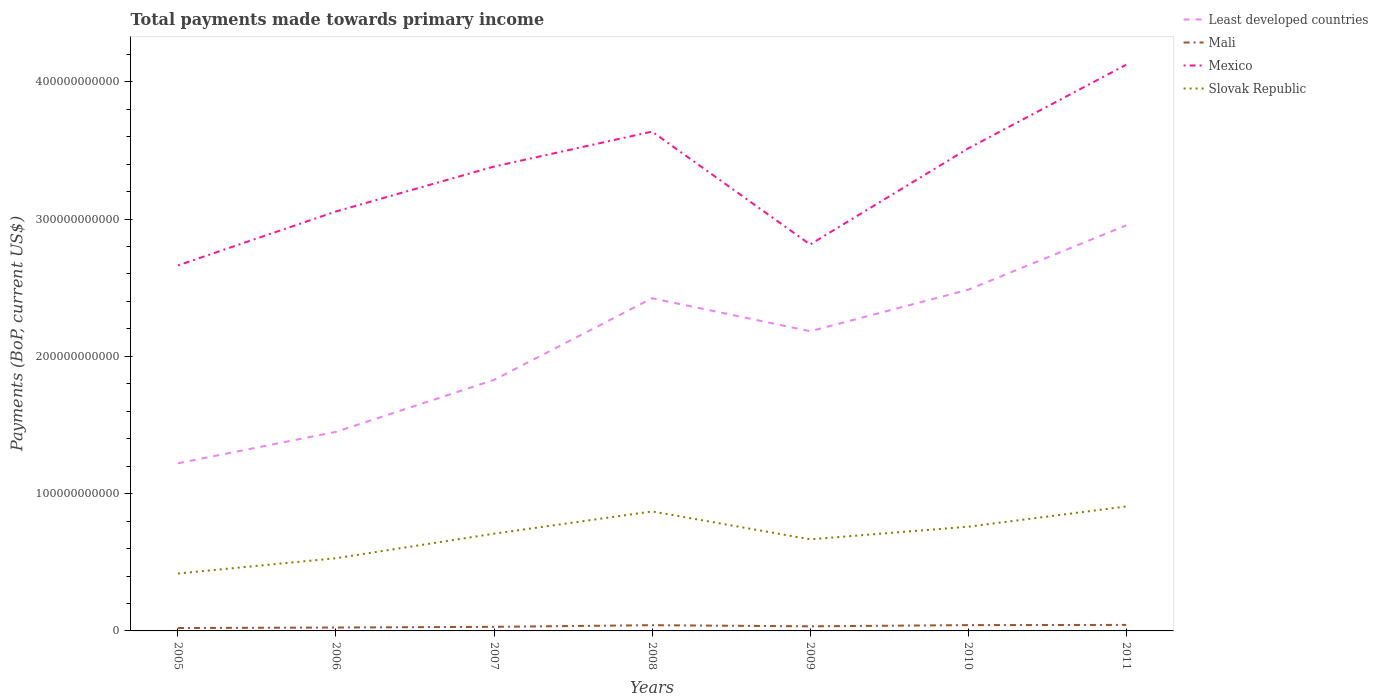How many different coloured lines are there?
Your answer should be compact. 4. Is the number of lines equal to the number of legend labels?
Your answer should be compact. Yes. Across all years, what is the maximum total payments made towards primary income in Mali?
Make the answer very short. 2.11e+09. What is the total total payments made towards primary income in Least developed countries in the graph?
Offer a very short reply. -9.62e+1. What is the difference between the highest and the second highest total payments made towards primary income in Slovak Republic?
Offer a very short reply. 4.88e+1. How many lines are there?
Your answer should be compact. 4. What is the difference between two consecutive major ticks on the Y-axis?
Make the answer very short. 1.00e+11. Does the graph contain any zero values?
Your answer should be compact. No. Does the graph contain grids?
Offer a terse response. No. Where does the legend appear in the graph?
Keep it short and to the point. Top right. How many legend labels are there?
Offer a terse response. 4. How are the legend labels stacked?
Give a very brief answer. Vertical. What is the title of the graph?
Offer a terse response. Total payments made towards primary income. What is the label or title of the Y-axis?
Make the answer very short. Payments (BoP, current US$). What is the Payments (BoP, current US$) in Least developed countries in 2005?
Provide a succinct answer. 1.22e+11. What is the Payments (BoP, current US$) in Mali in 2005?
Your answer should be compact. 2.11e+09. What is the Payments (BoP, current US$) in Mexico in 2005?
Ensure brevity in your answer.  2.66e+11. What is the Payments (BoP, current US$) of Slovak Republic in 2005?
Your response must be concise. 4.18e+1. What is the Payments (BoP, current US$) of Least developed countries in 2006?
Offer a very short reply. 1.45e+11. What is the Payments (BoP, current US$) in Mali in 2006?
Your answer should be compact. 2.48e+09. What is the Payments (BoP, current US$) of Mexico in 2006?
Provide a succinct answer. 3.06e+11. What is the Payments (BoP, current US$) of Slovak Republic in 2006?
Keep it short and to the point. 5.30e+1. What is the Payments (BoP, current US$) of Least developed countries in 2007?
Your answer should be very brief. 1.83e+11. What is the Payments (BoP, current US$) of Mali in 2007?
Ensure brevity in your answer.  2.99e+09. What is the Payments (BoP, current US$) in Mexico in 2007?
Offer a terse response. 3.38e+11. What is the Payments (BoP, current US$) of Slovak Republic in 2007?
Provide a short and direct response. 7.08e+1. What is the Payments (BoP, current US$) in Least developed countries in 2008?
Make the answer very short. 2.42e+11. What is the Payments (BoP, current US$) of Mali in 2008?
Provide a short and direct response. 4.17e+09. What is the Payments (BoP, current US$) of Mexico in 2008?
Ensure brevity in your answer.  3.64e+11. What is the Payments (BoP, current US$) in Slovak Republic in 2008?
Your answer should be very brief. 8.70e+1. What is the Payments (BoP, current US$) in Least developed countries in 2009?
Provide a short and direct response. 2.18e+11. What is the Payments (BoP, current US$) in Mali in 2009?
Your response must be concise. 3.35e+09. What is the Payments (BoP, current US$) in Mexico in 2009?
Provide a succinct answer. 2.82e+11. What is the Payments (BoP, current US$) in Slovak Republic in 2009?
Your response must be concise. 6.67e+1. What is the Payments (BoP, current US$) of Least developed countries in 2010?
Your answer should be compact. 2.49e+11. What is the Payments (BoP, current US$) of Mali in 2010?
Your answer should be compact. 4.24e+09. What is the Payments (BoP, current US$) in Mexico in 2010?
Provide a short and direct response. 3.51e+11. What is the Payments (BoP, current US$) of Slovak Republic in 2010?
Provide a succinct answer. 7.59e+1. What is the Payments (BoP, current US$) of Least developed countries in 2011?
Your answer should be very brief. 2.95e+11. What is the Payments (BoP, current US$) of Mali in 2011?
Offer a very short reply. 4.37e+09. What is the Payments (BoP, current US$) in Mexico in 2011?
Provide a short and direct response. 4.12e+11. What is the Payments (BoP, current US$) of Slovak Republic in 2011?
Provide a short and direct response. 9.07e+1. Across all years, what is the maximum Payments (BoP, current US$) of Least developed countries?
Offer a very short reply. 2.95e+11. Across all years, what is the maximum Payments (BoP, current US$) of Mali?
Your answer should be compact. 4.37e+09. Across all years, what is the maximum Payments (BoP, current US$) of Mexico?
Your response must be concise. 4.12e+11. Across all years, what is the maximum Payments (BoP, current US$) of Slovak Republic?
Give a very brief answer. 9.07e+1. Across all years, what is the minimum Payments (BoP, current US$) of Least developed countries?
Provide a short and direct response. 1.22e+11. Across all years, what is the minimum Payments (BoP, current US$) in Mali?
Offer a very short reply. 2.11e+09. Across all years, what is the minimum Payments (BoP, current US$) in Mexico?
Keep it short and to the point. 2.66e+11. Across all years, what is the minimum Payments (BoP, current US$) of Slovak Republic?
Provide a succinct answer. 4.18e+1. What is the total Payments (BoP, current US$) of Least developed countries in the graph?
Make the answer very short. 1.45e+12. What is the total Payments (BoP, current US$) of Mali in the graph?
Keep it short and to the point. 2.37e+1. What is the total Payments (BoP, current US$) of Mexico in the graph?
Provide a succinct answer. 2.32e+12. What is the total Payments (BoP, current US$) in Slovak Republic in the graph?
Your response must be concise. 4.86e+11. What is the difference between the Payments (BoP, current US$) of Least developed countries in 2005 and that in 2006?
Make the answer very short. -2.29e+1. What is the difference between the Payments (BoP, current US$) of Mali in 2005 and that in 2006?
Keep it short and to the point. -3.68e+08. What is the difference between the Payments (BoP, current US$) in Mexico in 2005 and that in 2006?
Ensure brevity in your answer.  -3.93e+1. What is the difference between the Payments (BoP, current US$) of Slovak Republic in 2005 and that in 2006?
Offer a terse response. -1.11e+1. What is the difference between the Payments (BoP, current US$) in Least developed countries in 2005 and that in 2007?
Offer a terse response. -6.07e+1. What is the difference between the Payments (BoP, current US$) of Mali in 2005 and that in 2007?
Your response must be concise. -8.77e+08. What is the difference between the Payments (BoP, current US$) of Mexico in 2005 and that in 2007?
Your response must be concise. -7.20e+1. What is the difference between the Payments (BoP, current US$) in Slovak Republic in 2005 and that in 2007?
Keep it short and to the point. -2.90e+1. What is the difference between the Payments (BoP, current US$) in Least developed countries in 2005 and that in 2008?
Provide a succinct answer. -1.20e+11. What is the difference between the Payments (BoP, current US$) of Mali in 2005 and that in 2008?
Make the answer very short. -2.06e+09. What is the difference between the Payments (BoP, current US$) of Mexico in 2005 and that in 2008?
Provide a short and direct response. -9.74e+1. What is the difference between the Payments (BoP, current US$) of Slovak Republic in 2005 and that in 2008?
Provide a short and direct response. -4.52e+1. What is the difference between the Payments (BoP, current US$) in Least developed countries in 2005 and that in 2009?
Ensure brevity in your answer.  -9.62e+1. What is the difference between the Payments (BoP, current US$) of Mali in 2005 and that in 2009?
Keep it short and to the point. -1.24e+09. What is the difference between the Payments (BoP, current US$) in Mexico in 2005 and that in 2009?
Ensure brevity in your answer.  -1.52e+1. What is the difference between the Payments (BoP, current US$) in Slovak Republic in 2005 and that in 2009?
Give a very brief answer. -2.49e+1. What is the difference between the Payments (BoP, current US$) in Least developed countries in 2005 and that in 2010?
Give a very brief answer. -1.26e+11. What is the difference between the Payments (BoP, current US$) of Mali in 2005 and that in 2010?
Your answer should be very brief. -2.13e+09. What is the difference between the Payments (BoP, current US$) of Mexico in 2005 and that in 2010?
Provide a succinct answer. -8.52e+1. What is the difference between the Payments (BoP, current US$) of Slovak Republic in 2005 and that in 2010?
Your response must be concise. -3.41e+1. What is the difference between the Payments (BoP, current US$) of Least developed countries in 2005 and that in 2011?
Keep it short and to the point. -1.73e+11. What is the difference between the Payments (BoP, current US$) of Mali in 2005 and that in 2011?
Give a very brief answer. -2.26e+09. What is the difference between the Payments (BoP, current US$) of Mexico in 2005 and that in 2011?
Your response must be concise. -1.46e+11. What is the difference between the Payments (BoP, current US$) of Slovak Republic in 2005 and that in 2011?
Provide a short and direct response. -4.88e+1. What is the difference between the Payments (BoP, current US$) of Least developed countries in 2006 and that in 2007?
Make the answer very short. -3.78e+1. What is the difference between the Payments (BoP, current US$) of Mali in 2006 and that in 2007?
Provide a short and direct response. -5.09e+08. What is the difference between the Payments (BoP, current US$) in Mexico in 2006 and that in 2007?
Provide a succinct answer. -3.27e+1. What is the difference between the Payments (BoP, current US$) in Slovak Republic in 2006 and that in 2007?
Give a very brief answer. -1.79e+1. What is the difference between the Payments (BoP, current US$) in Least developed countries in 2006 and that in 2008?
Your response must be concise. -9.73e+1. What is the difference between the Payments (BoP, current US$) of Mali in 2006 and that in 2008?
Make the answer very short. -1.70e+09. What is the difference between the Payments (BoP, current US$) of Mexico in 2006 and that in 2008?
Ensure brevity in your answer.  -5.82e+1. What is the difference between the Payments (BoP, current US$) of Slovak Republic in 2006 and that in 2008?
Provide a short and direct response. -3.41e+1. What is the difference between the Payments (BoP, current US$) of Least developed countries in 2006 and that in 2009?
Provide a short and direct response. -7.33e+1. What is the difference between the Payments (BoP, current US$) of Mali in 2006 and that in 2009?
Give a very brief answer. -8.75e+08. What is the difference between the Payments (BoP, current US$) in Mexico in 2006 and that in 2009?
Your answer should be very brief. 2.40e+1. What is the difference between the Payments (BoP, current US$) of Slovak Republic in 2006 and that in 2009?
Keep it short and to the point. -1.38e+1. What is the difference between the Payments (BoP, current US$) of Least developed countries in 2006 and that in 2010?
Your answer should be very brief. -1.04e+11. What is the difference between the Payments (BoP, current US$) of Mali in 2006 and that in 2010?
Offer a terse response. -1.76e+09. What is the difference between the Payments (BoP, current US$) of Mexico in 2006 and that in 2010?
Provide a succinct answer. -4.59e+1. What is the difference between the Payments (BoP, current US$) of Slovak Republic in 2006 and that in 2010?
Your answer should be compact. -2.30e+1. What is the difference between the Payments (BoP, current US$) in Least developed countries in 2006 and that in 2011?
Keep it short and to the point. -1.50e+11. What is the difference between the Payments (BoP, current US$) in Mali in 2006 and that in 2011?
Your answer should be compact. -1.89e+09. What is the difference between the Payments (BoP, current US$) in Mexico in 2006 and that in 2011?
Make the answer very short. -1.07e+11. What is the difference between the Payments (BoP, current US$) in Slovak Republic in 2006 and that in 2011?
Ensure brevity in your answer.  -3.77e+1. What is the difference between the Payments (BoP, current US$) of Least developed countries in 2007 and that in 2008?
Your answer should be very brief. -5.95e+1. What is the difference between the Payments (BoP, current US$) of Mali in 2007 and that in 2008?
Give a very brief answer. -1.19e+09. What is the difference between the Payments (BoP, current US$) in Mexico in 2007 and that in 2008?
Your answer should be compact. -2.55e+1. What is the difference between the Payments (BoP, current US$) of Slovak Republic in 2007 and that in 2008?
Ensure brevity in your answer.  -1.62e+1. What is the difference between the Payments (BoP, current US$) of Least developed countries in 2007 and that in 2009?
Your answer should be compact. -3.54e+1. What is the difference between the Payments (BoP, current US$) of Mali in 2007 and that in 2009?
Your response must be concise. -3.65e+08. What is the difference between the Payments (BoP, current US$) in Mexico in 2007 and that in 2009?
Your answer should be very brief. 5.68e+1. What is the difference between the Payments (BoP, current US$) of Slovak Republic in 2007 and that in 2009?
Make the answer very short. 4.10e+09. What is the difference between the Payments (BoP, current US$) of Least developed countries in 2007 and that in 2010?
Provide a succinct answer. -6.57e+1. What is the difference between the Payments (BoP, current US$) in Mali in 2007 and that in 2010?
Keep it short and to the point. -1.25e+09. What is the difference between the Payments (BoP, current US$) of Mexico in 2007 and that in 2010?
Offer a terse response. -1.32e+1. What is the difference between the Payments (BoP, current US$) in Slovak Republic in 2007 and that in 2010?
Your answer should be very brief. -5.08e+09. What is the difference between the Payments (BoP, current US$) in Least developed countries in 2007 and that in 2011?
Your answer should be compact. -1.13e+11. What is the difference between the Payments (BoP, current US$) in Mali in 2007 and that in 2011?
Give a very brief answer. -1.39e+09. What is the difference between the Payments (BoP, current US$) in Mexico in 2007 and that in 2011?
Keep it short and to the point. -7.42e+1. What is the difference between the Payments (BoP, current US$) in Slovak Republic in 2007 and that in 2011?
Keep it short and to the point. -1.98e+1. What is the difference between the Payments (BoP, current US$) of Least developed countries in 2008 and that in 2009?
Offer a terse response. 2.40e+1. What is the difference between the Payments (BoP, current US$) in Mali in 2008 and that in 2009?
Your answer should be very brief. 8.21e+08. What is the difference between the Payments (BoP, current US$) in Mexico in 2008 and that in 2009?
Offer a terse response. 8.22e+1. What is the difference between the Payments (BoP, current US$) of Slovak Republic in 2008 and that in 2009?
Your answer should be compact. 2.03e+1. What is the difference between the Payments (BoP, current US$) of Least developed countries in 2008 and that in 2010?
Your answer should be compact. -6.20e+09. What is the difference between the Payments (BoP, current US$) in Mali in 2008 and that in 2010?
Keep it short and to the point. -6.41e+07. What is the difference between the Payments (BoP, current US$) in Mexico in 2008 and that in 2010?
Provide a short and direct response. 1.23e+1. What is the difference between the Payments (BoP, current US$) of Slovak Republic in 2008 and that in 2010?
Keep it short and to the point. 1.11e+1. What is the difference between the Payments (BoP, current US$) in Least developed countries in 2008 and that in 2011?
Make the answer very short. -5.31e+1. What is the difference between the Payments (BoP, current US$) of Mali in 2008 and that in 2011?
Give a very brief answer. -2.00e+08. What is the difference between the Payments (BoP, current US$) in Mexico in 2008 and that in 2011?
Offer a very short reply. -4.87e+1. What is the difference between the Payments (BoP, current US$) of Slovak Republic in 2008 and that in 2011?
Ensure brevity in your answer.  -3.62e+09. What is the difference between the Payments (BoP, current US$) in Least developed countries in 2009 and that in 2010?
Your answer should be very brief. -3.02e+1. What is the difference between the Payments (BoP, current US$) of Mali in 2009 and that in 2010?
Offer a very short reply. -8.85e+08. What is the difference between the Payments (BoP, current US$) of Mexico in 2009 and that in 2010?
Your response must be concise. -7.00e+1. What is the difference between the Payments (BoP, current US$) of Slovak Republic in 2009 and that in 2010?
Your answer should be compact. -9.18e+09. What is the difference between the Payments (BoP, current US$) of Least developed countries in 2009 and that in 2011?
Make the answer very short. -7.71e+1. What is the difference between the Payments (BoP, current US$) of Mali in 2009 and that in 2011?
Your answer should be compact. -1.02e+09. What is the difference between the Payments (BoP, current US$) in Mexico in 2009 and that in 2011?
Provide a short and direct response. -1.31e+11. What is the difference between the Payments (BoP, current US$) of Slovak Republic in 2009 and that in 2011?
Keep it short and to the point. -2.39e+1. What is the difference between the Payments (BoP, current US$) in Least developed countries in 2010 and that in 2011?
Your answer should be very brief. -4.69e+1. What is the difference between the Payments (BoP, current US$) of Mali in 2010 and that in 2011?
Give a very brief answer. -1.36e+08. What is the difference between the Payments (BoP, current US$) in Mexico in 2010 and that in 2011?
Ensure brevity in your answer.  -6.10e+1. What is the difference between the Payments (BoP, current US$) in Slovak Republic in 2010 and that in 2011?
Provide a short and direct response. -1.47e+1. What is the difference between the Payments (BoP, current US$) in Least developed countries in 2005 and the Payments (BoP, current US$) in Mali in 2006?
Offer a terse response. 1.20e+11. What is the difference between the Payments (BoP, current US$) of Least developed countries in 2005 and the Payments (BoP, current US$) of Mexico in 2006?
Make the answer very short. -1.83e+11. What is the difference between the Payments (BoP, current US$) in Least developed countries in 2005 and the Payments (BoP, current US$) in Slovak Republic in 2006?
Your answer should be very brief. 6.92e+1. What is the difference between the Payments (BoP, current US$) of Mali in 2005 and the Payments (BoP, current US$) of Mexico in 2006?
Provide a succinct answer. -3.03e+11. What is the difference between the Payments (BoP, current US$) of Mali in 2005 and the Payments (BoP, current US$) of Slovak Republic in 2006?
Offer a terse response. -5.08e+1. What is the difference between the Payments (BoP, current US$) in Mexico in 2005 and the Payments (BoP, current US$) in Slovak Republic in 2006?
Ensure brevity in your answer.  2.13e+11. What is the difference between the Payments (BoP, current US$) in Least developed countries in 2005 and the Payments (BoP, current US$) in Mali in 2007?
Provide a succinct answer. 1.19e+11. What is the difference between the Payments (BoP, current US$) in Least developed countries in 2005 and the Payments (BoP, current US$) in Mexico in 2007?
Give a very brief answer. -2.16e+11. What is the difference between the Payments (BoP, current US$) of Least developed countries in 2005 and the Payments (BoP, current US$) of Slovak Republic in 2007?
Make the answer very short. 5.13e+1. What is the difference between the Payments (BoP, current US$) in Mali in 2005 and the Payments (BoP, current US$) in Mexico in 2007?
Provide a succinct answer. -3.36e+11. What is the difference between the Payments (BoP, current US$) in Mali in 2005 and the Payments (BoP, current US$) in Slovak Republic in 2007?
Your answer should be compact. -6.87e+1. What is the difference between the Payments (BoP, current US$) in Mexico in 2005 and the Payments (BoP, current US$) in Slovak Republic in 2007?
Provide a succinct answer. 1.95e+11. What is the difference between the Payments (BoP, current US$) in Least developed countries in 2005 and the Payments (BoP, current US$) in Mali in 2008?
Offer a terse response. 1.18e+11. What is the difference between the Payments (BoP, current US$) of Least developed countries in 2005 and the Payments (BoP, current US$) of Mexico in 2008?
Your response must be concise. -2.42e+11. What is the difference between the Payments (BoP, current US$) of Least developed countries in 2005 and the Payments (BoP, current US$) of Slovak Republic in 2008?
Keep it short and to the point. 3.51e+1. What is the difference between the Payments (BoP, current US$) of Mali in 2005 and the Payments (BoP, current US$) of Mexico in 2008?
Your answer should be very brief. -3.62e+11. What is the difference between the Payments (BoP, current US$) in Mali in 2005 and the Payments (BoP, current US$) in Slovak Republic in 2008?
Ensure brevity in your answer.  -8.49e+1. What is the difference between the Payments (BoP, current US$) of Mexico in 2005 and the Payments (BoP, current US$) of Slovak Republic in 2008?
Give a very brief answer. 1.79e+11. What is the difference between the Payments (BoP, current US$) of Least developed countries in 2005 and the Payments (BoP, current US$) of Mali in 2009?
Your answer should be compact. 1.19e+11. What is the difference between the Payments (BoP, current US$) of Least developed countries in 2005 and the Payments (BoP, current US$) of Mexico in 2009?
Your answer should be compact. -1.59e+11. What is the difference between the Payments (BoP, current US$) of Least developed countries in 2005 and the Payments (BoP, current US$) of Slovak Republic in 2009?
Provide a short and direct response. 5.54e+1. What is the difference between the Payments (BoP, current US$) of Mali in 2005 and the Payments (BoP, current US$) of Mexico in 2009?
Your response must be concise. -2.79e+11. What is the difference between the Payments (BoP, current US$) of Mali in 2005 and the Payments (BoP, current US$) of Slovak Republic in 2009?
Offer a very short reply. -6.46e+1. What is the difference between the Payments (BoP, current US$) in Mexico in 2005 and the Payments (BoP, current US$) in Slovak Republic in 2009?
Your response must be concise. 2.00e+11. What is the difference between the Payments (BoP, current US$) in Least developed countries in 2005 and the Payments (BoP, current US$) in Mali in 2010?
Provide a succinct answer. 1.18e+11. What is the difference between the Payments (BoP, current US$) of Least developed countries in 2005 and the Payments (BoP, current US$) of Mexico in 2010?
Offer a very short reply. -2.29e+11. What is the difference between the Payments (BoP, current US$) of Least developed countries in 2005 and the Payments (BoP, current US$) of Slovak Republic in 2010?
Your answer should be very brief. 4.62e+1. What is the difference between the Payments (BoP, current US$) in Mali in 2005 and the Payments (BoP, current US$) in Mexico in 2010?
Offer a terse response. -3.49e+11. What is the difference between the Payments (BoP, current US$) of Mali in 2005 and the Payments (BoP, current US$) of Slovak Republic in 2010?
Your answer should be compact. -7.38e+1. What is the difference between the Payments (BoP, current US$) in Mexico in 2005 and the Payments (BoP, current US$) in Slovak Republic in 2010?
Ensure brevity in your answer.  1.90e+11. What is the difference between the Payments (BoP, current US$) in Least developed countries in 2005 and the Payments (BoP, current US$) in Mali in 2011?
Your answer should be very brief. 1.18e+11. What is the difference between the Payments (BoP, current US$) in Least developed countries in 2005 and the Payments (BoP, current US$) in Mexico in 2011?
Offer a terse response. -2.90e+11. What is the difference between the Payments (BoP, current US$) in Least developed countries in 2005 and the Payments (BoP, current US$) in Slovak Republic in 2011?
Provide a succinct answer. 3.15e+1. What is the difference between the Payments (BoP, current US$) in Mali in 2005 and the Payments (BoP, current US$) in Mexico in 2011?
Your answer should be very brief. -4.10e+11. What is the difference between the Payments (BoP, current US$) of Mali in 2005 and the Payments (BoP, current US$) of Slovak Republic in 2011?
Make the answer very short. -8.85e+1. What is the difference between the Payments (BoP, current US$) in Mexico in 2005 and the Payments (BoP, current US$) in Slovak Republic in 2011?
Keep it short and to the point. 1.76e+11. What is the difference between the Payments (BoP, current US$) of Least developed countries in 2006 and the Payments (BoP, current US$) of Mali in 2007?
Give a very brief answer. 1.42e+11. What is the difference between the Payments (BoP, current US$) in Least developed countries in 2006 and the Payments (BoP, current US$) in Mexico in 2007?
Your answer should be compact. -1.93e+11. What is the difference between the Payments (BoP, current US$) of Least developed countries in 2006 and the Payments (BoP, current US$) of Slovak Republic in 2007?
Your response must be concise. 7.42e+1. What is the difference between the Payments (BoP, current US$) in Mali in 2006 and the Payments (BoP, current US$) in Mexico in 2007?
Offer a terse response. -3.36e+11. What is the difference between the Payments (BoP, current US$) in Mali in 2006 and the Payments (BoP, current US$) in Slovak Republic in 2007?
Your response must be concise. -6.84e+1. What is the difference between the Payments (BoP, current US$) in Mexico in 2006 and the Payments (BoP, current US$) in Slovak Republic in 2007?
Offer a very short reply. 2.35e+11. What is the difference between the Payments (BoP, current US$) in Least developed countries in 2006 and the Payments (BoP, current US$) in Mali in 2008?
Offer a very short reply. 1.41e+11. What is the difference between the Payments (BoP, current US$) of Least developed countries in 2006 and the Payments (BoP, current US$) of Mexico in 2008?
Ensure brevity in your answer.  -2.19e+11. What is the difference between the Payments (BoP, current US$) of Least developed countries in 2006 and the Payments (BoP, current US$) of Slovak Republic in 2008?
Your answer should be compact. 5.80e+1. What is the difference between the Payments (BoP, current US$) of Mali in 2006 and the Payments (BoP, current US$) of Mexico in 2008?
Ensure brevity in your answer.  -3.61e+11. What is the difference between the Payments (BoP, current US$) in Mali in 2006 and the Payments (BoP, current US$) in Slovak Republic in 2008?
Offer a terse response. -8.46e+1. What is the difference between the Payments (BoP, current US$) of Mexico in 2006 and the Payments (BoP, current US$) of Slovak Republic in 2008?
Offer a terse response. 2.19e+11. What is the difference between the Payments (BoP, current US$) in Least developed countries in 2006 and the Payments (BoP, current US$) in Mali in 2009?
Keep it short and to the point. 1.42e+11. What is the difference between the Payments (BoP, current US$) of Least developed countries in 2006 and the Payments (BoP, current US$) of Mexico in 2009?
Offer a terse response. -1.36e+11. What is the difference between the Payments (BoP, current US$) of Least developed countries in 2006 and the Payments (BoP, current US$) of Slovak Republic in 2009?
Give a very brief answer. 7.83e+1. What is the difference between the Payments (BoP, current US$) in Mali in 2006 and the Payments (BoP, current US$) in Mexico in 2009?
Offer a terse response. -2.79e+11. What is the difference between the Payments (BoP, current US$) in Mali in 2006 and the Payments (BoP, current US$) in Slovak Republic in 2009?
Provide a short and direct response. -6.43e+1. What is the difference between the Payments (BoP, current US$) of Mexico in 2006 and the Payments (BoP, current US$) of Slovak Republic in 2009?
Provide a succinct answer. 2.39e+11. What is the difference between the Payments (BoP, current US$) of Least developed countries in 2006 and the Payments (BoP, current US$) of Mali in 2010?
Give a very brief answer. 1.41e+11. What is the difference between the Payments (BoP, current US$) in Least developed countries in 2006 and the Payments (BoP, current US$) in Mexico in 2010?
Offer a terse response. -2.06e+11. What is the difference between the Payments (BoP, current US$) in Least developed countries in 2006 and the Payments (BoP, current US$) in Slovak Republic in 2010?
Keep it short and to the point. 6.91e+1. What is the difference between the Payments (BoP, current US$) of Mali in 2006 and the Payments (BoP, current US$) of Mexico in 2010?
Ensure brevity in your answer.  -3.49e+11. What is the difference between the Payments (BoP, current US$) of Mali in 2006 and the Payments (BoP, current US$) of Slovak Republic in 2010?
Your answer should be very brief. -7.34e+1. What is the difference between the Payments (BoP, current US$) in Mexico in 2006 and the Payments (BoP, current US$) in Slovak Republic in 2010?
Offer a terse response. 2.30e+11. What is the difference between the Payments (BoP, current US$) of Least developed countries in 2006 and the Payments (BoP, current US$) of Mali in 2011?
Your answer should be compact. 1.41e+11. What is the difference between the Payments (BoP, current US$) of Least developed countries in 2006 and the Payments (BoP, current US$) of Mexico in 2011?
Your answer should be very brief. -2.67e+11. What is the difference between the Payments (BoP, current US$) in Least developed countries in 2006 and the Payments (BoP, current US$) in Slovak Republic in 2011?
Your answer should be very brief. 5.44e+1. What is the difference between the Payments (BoP, current US$) in Mali in 2006 and the Payments (BoP, current US$) in Mexico in 2011?
Keep it short and to the point. -4.10e+11. What is the difference between the Payments (BoP, current US$) of Mali in 2006 and the Payments (BoP, current US$) of Slovak Republic in 2011?
Provide a succinct answer. -8.82e+1. What is the difference between the Payments (BoP, current US$) of Mexico in 2006 and the Payments (BoP, current US$) of Slovak Republic in 2011?
Offer a very short reply. 2.15e+11. What is the difference between the Payments (BoP, current US$) in Least developed countries in 2007 and the Payments (BoP, current US$) in Mali in 2008?
Offer a terse response. 1.79e+11. What is the difference between the Payments (BoP, current US$) of Least developed countries in 2007 and the Payments (BoP, current US$) of Mexico in 2008?
Offer a terse response. -1.81e+11. What is the difference between the Payments (BoP, current US$) in Least developed countries in 2007 and the Payments (BoP, current US$) in Slovak Republic in 2008?
Make the answer very short. 9.58e+1. What is the difference between the Payments (BoP, current US$) of Mali in 2007 and the Payments (BoP, current US$) of Mexico in 2008?
Keep it short and to the point. -3.61e+11. What is the difference between the Payments (BoP, current US$) of Mali in 2007 and the Payments (BoP, current US$) of Slovak Republic in 2008?
Your response must be concise. -8.40e+1. What is the difference between the Payments (BoP, current US$) in Mexico in 2007 and the Payments (BoP, current US$) in Slovak Republic in 2008?
Offer a very short reply. 2.51e+11. What is the difference between the Payments (BoP, current US$) in Least developed countries in 2007 and the Payments (BoP, current US$) in Mali in 2009?
Give a very brief answer. 1.80e+11. What is the difference between the Payments (BoP, current US$) of Least developed countries in 2007 and the Payments (BoP, current US$) of Mexico in 2009?
Provide a succinct answer. -9.86e+1. What is the difference between the Payments (BoP, current US$) in Least developed countries in 2007 and the Payments (BoP, current US$) in Slovak Republic in 2009?
Your answer should be very brief. 1.16e+11. What is the difference between the Payments (BoP, current US$) in Mali in 2007 and the Payments (BoP, current US$) in Mexico in 2009?
Make the answer very short. -2.79e+11. What is the difference between the Payments (BoP, current US$) of Mali in 2007 and the Payments (BoP, current US$) of Slovak Republic in 2009?
Provide a succinct answer. -6.37e+1. What is the difference between the Payments (BoP, current US$) of Mexico in 2007 and the Payments (BoP, current US$) of Slovak Republic in 2009?
Provide a short and direct response. 2.72e+11. What is the difference between the Payments (BoP, current US$) of Least developed countries in 2007 and the Payments (BoP, current US$) of Mali in 2010?
Give a very brief answer. 1.79e+11. What is the difference between the Payments (BoP, current US$) of Least developed countries in 2007 and the Payments (BoP, current US$) of Mexico in 2010?
Your response must be concise. -1.69e+11. What is the difference between the Payments (BoP, current US$) of Least developed countries in 2007 and the Payments (BoP, current US$) of Slovak Republic in 2010?
Make the answer very short. 1.07e+11. What is the difference between the Payments (BoP, current US$) in Mali in 2007 and the Payments (BoP, current US$) in Mexico in 2010?
Offer a terse response. -3.48e+11. What is the difference between the Payments (BoP, current US$) of Mali in 2007 and the Payments (BoP, current US$) of Slovak Republic in 2010?
Your answer should be very brief. -7.29e+1. What is the difference between the Payments (BoP, current US$) in Mexico in 2007 and the Payments (BoP, current US$) in Slovak Republic in 2010?
Make the answer very short. 2.62e+11. What is the difference between the Payments (BoP, current US$) of Least developed countries in 2007 and the Payments (BoP, current US$) of Mali in 2011?
Your answer should be very brief. 1.79e+11. What is the difference between the Payments (BoP, current US$) of Least developed countries in 2007 and the Payments (BoP, current US$) of Mexico in 2011?
Ensure brevity in your answer.  -2.30e+11. What is the difference between the Payments (BoP, current US$) of Least developed countries in 2007 and the Payments (BoP, current US$) of Slovak Republic in 2011?
Ensure brevity in your answer.  9.22e+1. What is the difference between the Payments (BoP, current US$) of Mali in 2007 and the Payments (BoP, current US$) of Mexico in 2011?
Your response must be concise. -4.09e+11. What is the difference between the Payments (BoP, current US$) of Mali in 2007 and the Payments (BoP, current US$) of Slovak Republic in 2011?
Keep it short and to the point. -8.77e+1. What is the difference between the Payments (BoP, current US$) of Mexico in 2007 and the Payments (BoP, current US$) of Slovak Republic in 2011?
Your answer should be very brief. 2.48e+11. What is the difference between the Payments (BoP, current US$) of Least developed countries in 2008 and the Payments (BoP, current US$) of Mali in 2009?
Offer a very short reply. 2.39e+11. What is the difference between the Payments (BoP, current US$) of Least developed countries in 2008 and the Payments (BoP, current US$) of Mexico in 2009?
Offer a terse response. -3.92e+1. What is the difference between the Payments (BoP, current US$) of Least developed countries in 2008 and the Payments (BoP, current US$) of Slovak Republic in 2009?
Ensure brevity in your answer.  1.76e+11. What is the difference between the Payments (BoP, current US$) in Mali in 2008 and the Payments (BoP, current US$) in Mexico in 2009?
Keep it short and to the point. -2.77e+11. What is the difference between the Payments (BoP, current US$) in Mali in 2008 and the Payments (BoP, current US$) in Slovak Republic in 2009?
Your response must be concise. -6.26e+1. What is the difference between the Payments (BoP, current US$) in Mexico in 2008 and the Payments (BoP, current US$) in Slovak Republic in 2009?
Provide a short and direct response. 2.97e+11. What is the difference between the Payments (BoP, current US$) in Least developed countries in 2008 and the Payments (BoP, current US$) in Mali in 2010?
Provide a short and direct response. 2.38e+11. What is the difference between the Payments (BoP, current US$) in Least developed countries in 2008 and the Payments (BoP, current US$) in Mexico in 2010?
Offer a terse response. -1.09e+11. What is the difference between the Payments (BoP, current US$) in Least developed countries in 2008 and the Payments (BoP, current US$) in Slovak Republic in 2010?
Make the answer very short. 1.66e+11. What is the difference between the Payments (BoP, current US$) in Mali in 2008 and the Payments (BoP, current US$) in Mexico in 2010?
Give a very brief answer. -3.47e+11. What is the difference between the Payments (BoP, current US$) of Mali in 2008 and the Payments (BoP, current US$) of Slovak Republic in 2010?
Offer a very short reply. -7.17e+1. What is the difference between the Payments (BoP, current US$) of Mexico in 2008 and the Payments (BoP, current US$) of Slovak Republic in 2010?
Keep it short and to the point. 2.88e+11. What is the difference between the Payments (BoP, current US$) of Least developed countries in 2008 and the Payments (BoP, current US$) of Mali in 2011?
Ensure brevity in your answer.  2.38e+11. What is the difference between the Payments (BoP, current US$) in Least developed countries in 2008 and the Payments (BoP, current US$) in Mexico in 2011?
Your answer should be compact. -1.70e+11. What is the difference between the Payments (BoP, current US$) in Least developed countries in 2008 and the Payments (BoP, current US$) in Slovak Republic in 2011?
Give a very brief answer. 1.52e+11. What is the difference between the Payments (BoP, current US$) in Mali in 2008 and the Payments (BoP, current US$) in Mexico in 2011?
Ensure brevity in your answer.  -4.08e+11. What is the difference between the Payments (BoP, current US$) of Mali in 2008 and the Payments (BoP, current US$) of Slovak Republic in 2011?
Give a very brief answer. -8.65e+1. What is the difference between the Payments (BoP, current US$) in Mexico in 2008 and the Payments (BoP, current US$) in Slovak Republic in 2011?
Offer a very short reply. 2.73e+11. What is the difference between the Payments (BoP, current US$) of Least developed countries in 2009 and the Payments (BoP, current US$) of Mali in 2010?
Keep it short and to the point. 2.14e+11. What is the difference between the Payments (BoP, current US$) of Least developed countries in 2009 and the Payments (BoP, current US$) of Mexico in 2010?
Offer a very short reply. -1.33e+11. What is the difference between the Payments (BoP, current US$) of Least developed countries in 2009 and the Payments (BoP, current US$) of Slovak Republic in 2010?
Offer a terse response. 1.42e+11. What is the difference between the Payments (BoP, current US$) of Mali in 2009 and the Payments (BoP, current US$) of Mexico in 2010?
Provide a short and direct response. -3.48e+11. What is the difference between the Payments (BoP, current US$) in Mali in 2009 and the Payments (BoP, current US$) in Slovak Republic in 2010?
Provide a succinct answer. -7.26e+1. What is the difference between the Payments (BoP, current US$) of Mexico in 2009 and the Payments (BoP, current US$) of Slovak Republic in 2010?
Offer a terse response. 2.06e+11. What is the difference between the Payments (BoP, current US$) of Least developed countries in 2009 and the Payments (BoP, current US$) of Mali in 2011?
Your answer should be very brief. 2.14e+11. What is the difference between the Payments (BoP, current US$) of Least developed countries in 2009 and the Payments (BoP, current US$) of Mexico in 2011?
Offer a very short reply. -1.94e+11. What is the difference between the Payments (BoP, current US$) in Least developed countries in 2009 and the Payments (BoP, current US$) in Slovak Republic in 2011?
Ensure brevity in your answer.  1.28e+11. What is the difference between the Payments (BoP, current US$) of Mali in 2009 and the Payments (BoP, current US$) of Mexico in 2011?
Your response must be concise. -4.09e+11. What is the difference between the Payments (BoP, current US$) in Mali in 2009 and the Payments (BoP, current US$) in Slovak Republic in 2011?
Offer a very short reply. -8.73e+1. What is the difference between the Payments (BoP, current US$) of Mexico in 2009 and the Payments (BoP, current US$) of Slovak Republic in 2011?
Make the answer very short. 1.91e+11. What is the difference between the Payments (BoP, current US$) of Least developed countries in 2010 and the Payments (BoP, current US$) of Mali in 2011?
Provide a short and direct response. 2.44e+11. What is the difference between the Payments (BoP, current US$) in Least developed countries in 2010 and the Payments (BoP, current US$) in Mexico in 2011?
Make the answer very short. -1.64e+11. What is the difference between the Payments (BoP, current US$) in Least developed countries in 2010 and the Payments (BoP, current US$) in Slovak Republic in 2011?
Keep it short and to the point. 1.58e+11. What is the difference between the Payments (BoP, current US$) in Mali in 2010 and the Payments (BoP, current US$) in Mexico in 2011?
Offer a terse response. -4.08e+11. What is the difference between the Payments (BoP, current US$) of Mali in 2010 and the Payments (BoP, current US$) of Slovak Republic in 2011?
Your answer should be compact. -8.64e+1. What is the difference between the Payments (BoP, current US$) of Mexico in 2010 and the Payments (BoP, current US$) of Slovak Republic in 2011?
Offer a terse response. 2.61e+11. What is the average Payments (BoP, current US$) in Least developed countries per year?
Give a very brief answer. 2.08e+11. What is the average Payments (BoP, current US$) of Mali per year?
Your answer should be compact. 3.39e+09. What is the average Payments (BoP, current US$) of Mexico per year?
Your answer should be compact. 3.31e+11. What is the average Payments (BoP, current US$) in Slovak Republic per year?
Provide a succinct answer. 6.94e+1. In the year 2005, what is the difference between the Payments (BoP, current US$) in Least developed countries and Payments (BoP, current US$) in Mali?
Offer a terse response. 1.20e+11. In the year 2005, what is the difference between the Payments (BoP, current US$) in Least developed countries and Payments (BoP, current US$) in Mexico?
Keep it short and to the point. -1.44e+11. In the year 2005, what is the difference between the Payments (BoP, current US$) in Least developed countries and Payments (BoP, current US$) in Slovak Republic?
Your response must be concise. 8.03e+1. In the year 2005, what is the difference between the Payments (BoP, current US$) of Mali and Payments (BoP, current US$) of Mexico?
Give a very brief answer. -2.64e+11. In the year 2005, what is the difference between the Payments (BoP, current US$) of Mali and Payments (BoP, current US$) of Slovak Republic?
Your answer should be very brief. -3.97e+1. In the year 2005, what is the difference between the Payments (BoP, current US$) of Mexico and Payments (BoP, current US$) of Slovak Republic?
Your response must be concise. 2.24e+11. In the year 2006, what is the difference between the Payments (BoP, current US$) in Least developed countries and Payments (BoP, current US$) in Mali?
Your response must be concise. 1.43e+11. In the year 2006, what is the difference between the Payments (BoP, current US$) of Least developed countries and Payments (BoP, current US$) of Mexico?
Your answer should be compact. -1.61e+11. In the year 2006, what is the difference between the Payments (BoP, current US$) of Least developed countries and Payments (BoP, current US$) of Slovak Republic?
Offer a terse response. 9.21e+1. In the year 2006, what is the difference between the Payments (BoP, current US$) in Mali and Payments (BoP, current US$) in Mexico?
Offer a terse response. -3.03e+11. In the year 2006, what is the difference between the Payments (BoP, current US$) of Mali and Payments (BoP, current US$) of Slovak Republic?
Your response must be concise. -5.05e+1. In the year 2006, what is the difference between the Payments (BoP, current US$) of Mexico and Payments (BoP, current US$) of Slovak Republic?
Keep it short and to the point. 2.53e+11. In the year 2007, what is the difference between the Payments (BoP, current US$) in Least developed countries and Payments (BoP, current US$) in Mali?
Your answer should be very brief. 1.80e+11. In the year 2007, what is the difference between the Payments (BoP, current US$) in Least developed countries and Payments (BoP, current US$) in Mexico?
Your response must be concise. -1.55e+11. In the year 2007, what is the difference between the Payments (BoP, current US$) in Least developed countries and Payments (BoP, current US$) in Slovak Republic?
Keep it short and to the point. 1.12e+11. In the year 2007, what is the difference between the Payments (BoP, current US$) in Mali and Payments (BoP, current US$) in Mexico?
Keep it short and to the point. -3.35e+11. In the year 2007, what is the difference between the Payments (BoP, current US$) of Mali and Payments (BoP, current US$) of Slovak Republic?
Give a very brief answer. -6.78e+1. In the year 2007, what is the difference between the Payments (BoP, current US$) of Mexico and Payments (BoP, current US$) of Slovak Republic?
Provide a short and direct response. 2.67e+11. In the year 2008, what is the difference between the Payments (BoP, current US$) of Least developed countries and Payments (BoP, current US$) of Mali?
Your answer should be very brief. 2.38e+11. In the year 2008, what is the difference between the Payments (BoP, current US$) in Least developed countries and Payments (BoP, current US$) in Mexico?
Offer a terse response. -1.21e+11. In the year 2008, what is the difference between the Payments (BoP, current US$) of Least developed countries and Payments (BoP, current US$) of Slovak Republic?
Your answer should be compact. 1.55e+11. In the year 2008, what is the difference between the Payments (BoP, current US$) in Mali and Payments (BoP, current US$) in Mexico?
Give a very brief answer. -3.60e+11. In the year 2008, what is the difference between the Payments (BoP, current US$) in Mali and Payments (BoP, current US$) in Slovak Republic?
Make the answer very short. -8.29e+1. In the year 2008, what is the difference between the Payments (BoP, current US$) in Mexico and Payments (BoP, current US$) in Slovak Republic?
Offer a very short reply. 2.77e+11. In the year 2009, what is the difference between the Payments (BoP, current US$) of Least developed countries and Payments (BoP, current US$) of Mali?
Provide a succinct answer. 2.15e+11. In the year 2009, what is the difference between the Payments (BoP, current US$) of Least developed countries and Payments (BoP, current US$) of Mexico?
Offer a terse response. -6.32e+1. In the year 2009, what is the difference between the Payments (BoP, current US$) in Least developed countries and Payments (BoP, current US$) in Slovak Republic?
Your answer should be very brief. 1.52e+11. In the year 2009, what is the difference between the Payments (BoP, current US$) of Mali and Payments (BoP, current US$) of Mexico?
Make the answer very short. -2.78e+11. In the year 2009, what is the difference between the Payments (BoP, current US$) of Mali and Payments (BoP, current US$) of Slovak Republic?
Your answer should be very brief. -6.34e+1. In the year 2009, what is the difference between the Payments (BoP, current US$) in Mexico and Payments (BoP, current US$) in Slovak Republic?
Provide a short and direct response. 2.15e+11. In the year 2010, what is the difference between the Payments (BoP, current US$) in Least developed countries and Payments (BoP, current US$) in Mali?
Provide a short and direct response. 2.44e+11. In the year 2010, what is the difference between the Payments (BoP, current US$) of Least developed countries and Payments (BoP, current US$) of Mexico?
Offer a very short reply. -1.03e+11. In the year 2010, what is the difference between the Payments (BoP, current US$) in Least developed countries and Payments (BoP, current US$) in Slovak Republic?
Give a very brief answer. 1.73e+11. In the year 2010, what is the difference between the Payments (BoP, current US$) in Mali and Payments (BoP, current US$) in Mexico?
Ensure brevity in your answer.  -3.47e+11. In the year 2010, what is the difference between the Payments (BoP, current US$) of Mali and Payments (BoP, current US$) of Slovak Republic?
Offer a terse response. -7.17e+1. In the year 2010, what is the difference between the Payments (BoP, current US$) in Mexico and Payments (BoP, current US$) in Slovak Republic?
Make the answer very short. 2.76e+11. In the year 2011, what is the difference between the Payments (BoP, current US$) of Least developed countries and Payments (BoP, current US$) of Mali?
Your answer should be compact. 2.91e+11. In the year 2011, what is the difference between the Payments (BoP, current US$) in Least developed countries and Payments (BoP, current US$) in Mexico?
Your response must be concise. -1.17e+11. In the year 2011, what is the difference between the Payments (BoP, current US$) of Least developed countries and Payments (BoP, current US$) of Slovak Republic?
Offer a very short reply. 2.05e+11. In the year 2011, what is the difference between the Payments (BoP, current US$) in Mali and Payments (BoP, current US$) in Mexico?
Give a very brief answer. -4.08e+11. In the year 2011, what is the difference between the Payments (BoP, current US$) of Mali and Payments (BoP, current US$) of Slovak Republic?
Provide a succinct answer. -8.63e+1. In the year 2011, what is the difference between the Payments (BoP, current US$) of Mexico and Payments (BoP, current US$) of Slovak Republic?
Your answer should be very brief. 3.22e+11. What is the ratio of the Payments (BoP, current US$) of Least developed countries in 2005 to that in 2006?
Your answer should be very brief. 0.84. What is the ratio of the Payments (BoP, current US$) of Mali in 2005 to that in 2006?
Make the answer very short. 0.85. What is the ratio of the Payments (BoP, current US$) in Mexico in 2005 to that in 2006?
Your answer should be compact. 0.87. What is the ratio of the Payments (BoP, current US$) of Slovak Republic in 2005 to that in 2006?
Give a very brief answer. 0.79. What is the ratio of the Payments (BoP, current US$) in Least developed countries in 2005 to that in 2007?
Make the answer very short. 0.67. What is the ratio of the Payments (BoP, current US$) of Mali in 2005 to that in 2007?
Make the answer very short. 0.71. What is the ratio of the Payments (BoP, current US$) of Mexico in 2005 to that in 2007?
Your answer should be very brief. 0.79. What is the ratio of the Payments (BoP, current US$) of Slovak Republic in 2005 to that in 2007?
Your answer should be compact. 0.59. What is the ratio of the Payments (BoP, current US$) of Least developed countries in 2005 to that in 2008?
Your answer should be compact. 0.5. What is the ratio of the Payments (BoP, current US$) in Mali in 2005 to that in 2008?
Give a very brief answer. 0.51. What is the ratio of the Payments (BoP, current US$) of Mexico in 2005 to that in 2008?
Provide a short and direct response. 0.73. What is the ratio of the Payments (BoP, current US$) in Slovak Republic in 2005 to that in 2008?
Provide a short and direct response. 0.48. What is the ratio of the Payments (BoP, current US$) of Least developed countries in 2005 to that in 2009?
Your answer should be very brief. 0.56. What is the ratio of the Payments (BoP, current US$) in Mali in 2005 to that in 2009?
Offer a very short reply. 0.63. What is the ratio of the Payments (BoP, current US$) in Mexico in 2005 to that in 2009?
Ensure brevity in your answer.  0.95. What is the ratio of the Payments (BoP, current US$) in Slovak Republic in 2005 to that in 2009?
Provide a succinct answer. 0.63. What is the ratio of the Payments (BoP, current US$) in Least developed countries in 2005 to that in 2010?
Provide a short and direct response. 0.49. What is the ratio of the Payments (BoP, current US$) of Mali in 2005 to that in 2010?
Your answer should be compact. 0.5. What is the ratio of the Payments (BoP, current US$) of Mexico in 2005 to that in 2010?
Provide a short and direct response. 0.76. What is the ratio of the Payments (BoP, current US$) in Slovak Republic in 2005 to that in 2010?
Ensure brevity in your answer.  0.55. What is the ratio of the Payments (BoP, current US$) in Least developed countries in 2005 to that in 2011?
Offer a very short reply. 0.41. What is the ratio of the Payments (BoP, current US$) in Mali in 2005 to that in 2011?
Provide a short and direct response. 0.48. What is the ratio of the Payments (BoP, current US$) in Mexico in 2005 to that in 2011?
Your response must be concise. 0.65. What is the ratio of the Payments (BoP, current US$) in Slovak Republic in 2005 to that in 2011?
Ensure brevity in your answer.  0.46. What is the ratio of the Payments (BoP, current US$) of Least developed countries in 2006 to that in 2007?
Your answer should be compact. 0.79. What is the ratio of the Payments (BoP, current US$) in Mali in 2006 to that in 2007?
Your response must be concise. 0.83. What is the ratio of the Payments (BoP, current US$) of Mexico in 2006 to that in 2007?
Ensure brevity in your answer.  0.9. What is the ratio of the Payments (BoP, current US$) of Slovak Republic in 2006 to that in 2007?
Offer a terse response. 0.75. What is the ratio of the Payments (BoP, current US$) in Least developed countries in 2006 to that in 2008?
Provide a short and direct response. 0.6. What is the ratio of the Payments (BoP, current US$) of Mali in 2006 to that in 2008?
Your response must be concise. 0.59. What is the ratio of the Payments (BoP, current US$) in Mexico in 2006 to that in 2008?
Your answer should be very brief. 0.84. What is the ratio of the Payments (BoP, current US$) in Slovak Republic in 2006 to that in 2008?
Give a very brief answer. 0.61. What is the ratio of the Payments (BoP, current US$) of Least developed countries in 2006 to that in 2009?
Your response must be concise. 0.66. What is the ratio of the Payments (BoP, current US$) in Mali in 2006 to that in 2009?
Keep it short and to the point. 0.74. What is the ratio of the Payments (BoP, current US$) in Mexico in 2006 to that in 2009?
Your answer should be compact. 1.09. What is the ratio of the Payments (BoP, current US$) of Slovak Republic in 2006 to that in 2009?
Offer a terse response. 0.79. What is the ratio of the Payments (BoP, current US$) in Least developed countries in 2006 to that in 2010?
Your response must be concise. 0.58. What is the ratio of the Payments (BoP, current US$) of Mali in 2006 to that in 2010?
Your answer should be very brief. 0.58. What is the ratio of the Payments (BoP, current US$) of Mexico in 2006 to that in 2010?
Provide a succinct answer. 0.87. What is the ratio of the Payments (BoP, current US$) of Slovak Republic in 2006 to that in 2010?
Give a very brief answer. 0.7. What is the ratio of the Payments (BoP, current US$) in Least developed countries in 2006 to that in 2011?
Offer a very short reply. 0.49. What is the ratio of the Payments (BoP, current US$) in Mali in 2006 to that in 2011?
Provide a succinct answer. 0.57. What is the ratio of the Payments (BoP, current US$) in Mexico in 2006 to that in 2011?
Give a very brief answer. 0.74. What is the ratio of the Payments (BoP, current US$) in Slovak Republic in 2006 to that in 2011?
Provide a succinct answer. 0.58. What is the ratio of the Payments (BoP, current US$) of Least developed countries in 2007 to that in 2008?
Offer a very short reply. 0.75. What is the ratio of the Payments (BoP, current US$) of Mali in 2007 to that in 2008?
Make the answer very short. 0.72. What is the ratio of the Payments (BoP, current US$) of Slovak Republic in 2007 to that in 2008?
Ensure brevity in your answer.  0.81. What is the ratio of the Payments (BoP, current US$) of Least developed countries in 2007 to that in 2009?
Give a very brief answer. 0.84. What is the ratio of the Payments (BoP, current US$) in Mali in 2007 to that in 2009?
Keep it short and to the point. 0.89. What is the ratio of the Payments (BoP, current US$) in Mexico in 2007 to that in 2009?
Provide a short and direct response. 1.2. What is the ratio of the Payments (BoP, current US$) of Slovak Republic in 2007 to that in 2009?
Provide a succinct answer. 1.06. What is the ratio of the Payments (BoP, current US$) in Least developed countries in 2007 to that in 2010?
Your answer should be very brief. 0.74. What is the ratio of the Payments (BoP, current US$) of Mali in 2007 to that in 2010?
Keep it short and to the point. 0.7. What is the ratio of the Payments (BoP, current US$) in Mexico in 2007 to that in 2010?
Offer a very short reply. 0.96. What is the ratio of the Payments (BoP, current US$) in Slovak Republic in 2007 to that in 2010?
Offer a very short reply. 0.93. What is the ratio of the Payments (BoP, current US$) of Least developed countries in 2007 to that in 2011?
Offer a very short reply. 0.62. What is the ratio of the Payments (BoP, current US$) in Mali in 2007 to that in 2011?
Make the answer very short. 0.68. What is the ratio of the Payments (BoP, current US$) of Mexico in 2007 to that in 2011?
Give a very brief answer. 0.82. What is the ratio of the Payments (BoP, current US$) in Slovak Republic in 2007 to that in 2011?
Keep it short and to the point. 0.78. What is the ratio of the Payments (BoP, current US$) in Least developed countries in 2008 to that in 2009?
Your answer should be compact. 1.11. What is the ratio of the Payments (BoP, current US$) in Mali in 2008 to that in 2009?
Your response must be concise. 1.24. What is the ratio of the Payments (BoP, current US$) of Mexico in 2008 to that in 2009?
Make the answer very short. 1.29. What is the ratio of the Payments (BoP, current US$) in Slovak Republic in 2008 to that in 2009?
Keep it short and to the point. 1.3. What is the ratio of the Payments (BoP, current US$) of Mali in 2008 to that in 2010?
Provide a short and direct response. 0.98. What is the ratio of the Payments (BoP, current US$) of Mexico in 2008 to that in 2010?
Keep it short and to the point. 1.03. What is the ratio of the Payments (BoP, current US$) in Slovak Republic in 2008 to that in 2010?
Your answer should be compact. 1.15. What is the ratio of the Payments (BoP, current US$) in Least developed countries in 2008 to that in 2011?
Offer a terse response. 0.82. What is the ratio of the Payments (BoP, current US$) of Mali in 2008 to that in 2011?
Offer a very short reply. 0.95. What is the ratio of the Payments (BoP, current US$) in Mexico in 2008 to that in 2011?
Make the answer very short. 0.88. What is the ratio of the Payments (BoP, current US$) of Slovak Republic in 2008 to that in 2011?
Offer a very short reply. 0.96. What is the ratio of the Payments (BoP, current US$) in Least developed countries in 2009 to that in 2010?
Make the answer very short. 0.88. What is the ratio of the Payments (BoP, current US$) of Mali in 2009 to that in 2010?
Your answer should be very brief. 0.79. What is the ratio of the Payments (BoP, current US$) in Mexico in 2009 to that in 2010?
Offer a terse response. 0.8. What is the ratio of the Payments (BoP, current US$) in Slovak Republic in 2009 to that in 2010?
Keep it short and to the point. 0.88. What is the ratio of the Payments (BoP, current US$) of Least developed countries in 2009 to that in 2011?
Provide a succinct answer. 0.74. What is the ratio of the Payments (BoP, current US$) of Mali in 2009 to that in 2011?
Keep it short and to the point. 0.77. What is the ratio of the Payments (BoP, current US$) in Mexico in 2009 to that in 2011?
Keep it short and to the point. 0.68. What is the ratio of the Payments (BoP, current US$) of Slovak Republic in 2009 to that in 2011?
Provide a short and direct response. 0.74. What is the ratio of the Payments (BoP, current US$) of Least developed countries in 2010 to that in 2011?
Provide a short and direct response. 0.84. What is the ratio of the Payments (BoP, current US$) in Mexico in 2010 to that in 2011?
Ensure brevity in your answer.  0.85. What is the ratio of the Payments (BoP, current US$) in Slovak Republic in 2010 to that in 2011?
Provide a short and direct response. 0.84. What is the difference between the highest and the second highest Payments (BoP, current US$) in Least developed countries?
Offer a very short reply. 4.69e+1. What is the difference between the highest and the second highest Payments (BoP, current US$) in Mali?
Make the answer very short. 1.36e+08. What is the difference between the highest and the second highest Payments (BoP, current US$) of Mexico?
Your answer should be very brief. 4.87e+1. What is the difference between the highest and the second highest Payments (BoP, current US$) in Slovak Republic?
Your response must be concise. 3.62e+09. What is the difference between the highest and the lowest Payments (BoP, current US$) in Least developed countries?
Offer a terse response. 1.73e+11. What is the difference between the highest and the lowest Payments (BoP, current US$) of Mali?
Your answer should be very brief. 2.26e+09. What is the difference between the highest and the lowest Payments (BoP, current US$) of Mexico?
Your response must be concise. 1.46e+11. What is the difference between the highest and the lowest Payments (BoP, current US$) of Slovak Republic?
Your answer should be very brief. 4.88e+1. 